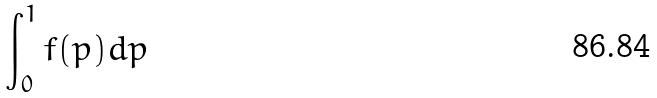<formula> <loc_0><loc_0><loc_500><loc_500>\int _ { 0 } ^ { 1 } f ( p ) d p</formula> 